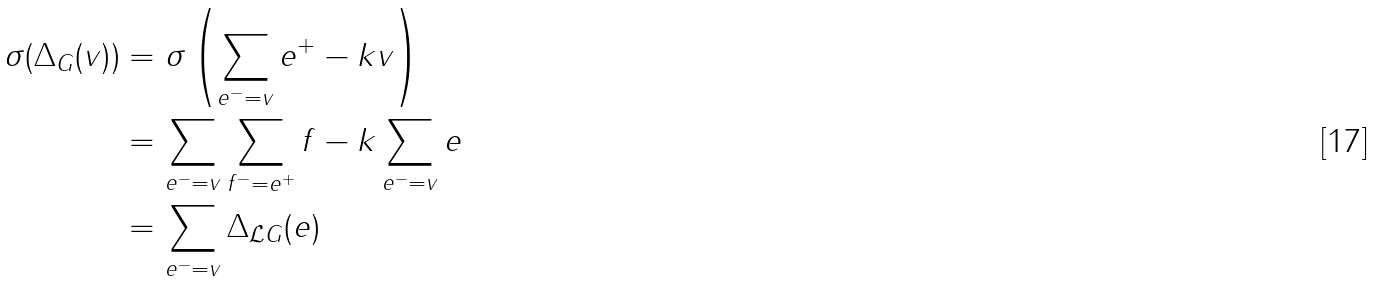<formula> <loc_0><loc_0><loc_500><loc_500>\sigma ( \Delta _ { G } ( v ) ) & = \sigma \left ( \sum _ { e ^ { - } = v } e ^ { + } - k v \right ) \\ & = \sum _ { e ^ { - } = v } \sum _ { f ^ { - } = e ^ { + } } f - k \sum _ { e ^ { - } = v } e \\ & = \sum _ { e ^ { - } = v } \Delta _ { \mathcal { L } G } ( e )</formula> 